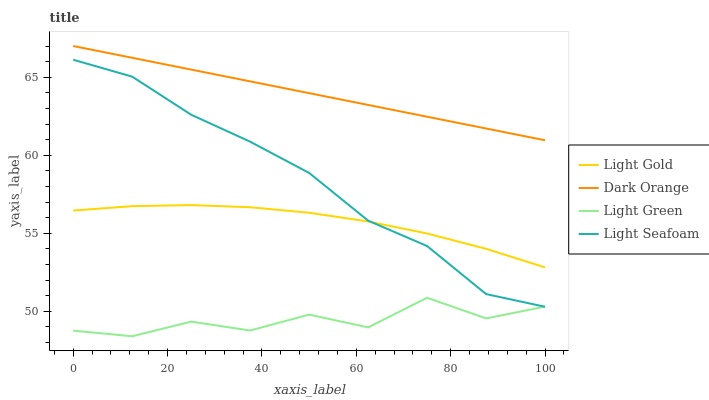Does Light Green have the minimum area under the curve?
Answer yes or no. Yes. Does Dark Orange have the maximum area under the curve?
Answer yes or no. Yes. Does Light Seafoam have the minimum area under the curve?
Answer yes or no. No. Does Light Seafoam have the maximum area under the curve?
Answer yes or no. No. Is Dark Orange the smoothest?
Answer yes or no. Yes. Is Light Green the roughest?
Answer yes or no. Yes. Is Light Seafoam the smoothest?
Answer yes or no. No. Is Light Seafoam the roughest?
Answer yes or no. No. Does Light Green have the lowest value?
Answer yes or no. Yes. Does Light Seafoam have the lowest value?
Answer yes or no. No. Does Dark Orange have the highest value?
Answer yes or no. Yes. Does Light Seafoam have the highest value?
Answer yes or no. No. Is Light Green less than Light Gold?
Answer yes or no. Yes. Is Dark Orange greater than Light Gold?
Answer yes or no. Yes. Does Light Seafoam intersect Light Green?
Answer yes or no. Yes. Is Light Seafoam less than Light Green?
Answer yes or no. No. Is Light Seafoam greater than Light Green?
Answer yes or no. No. Does Light Green intersect Light Gold?
Answer yes or no. No. 